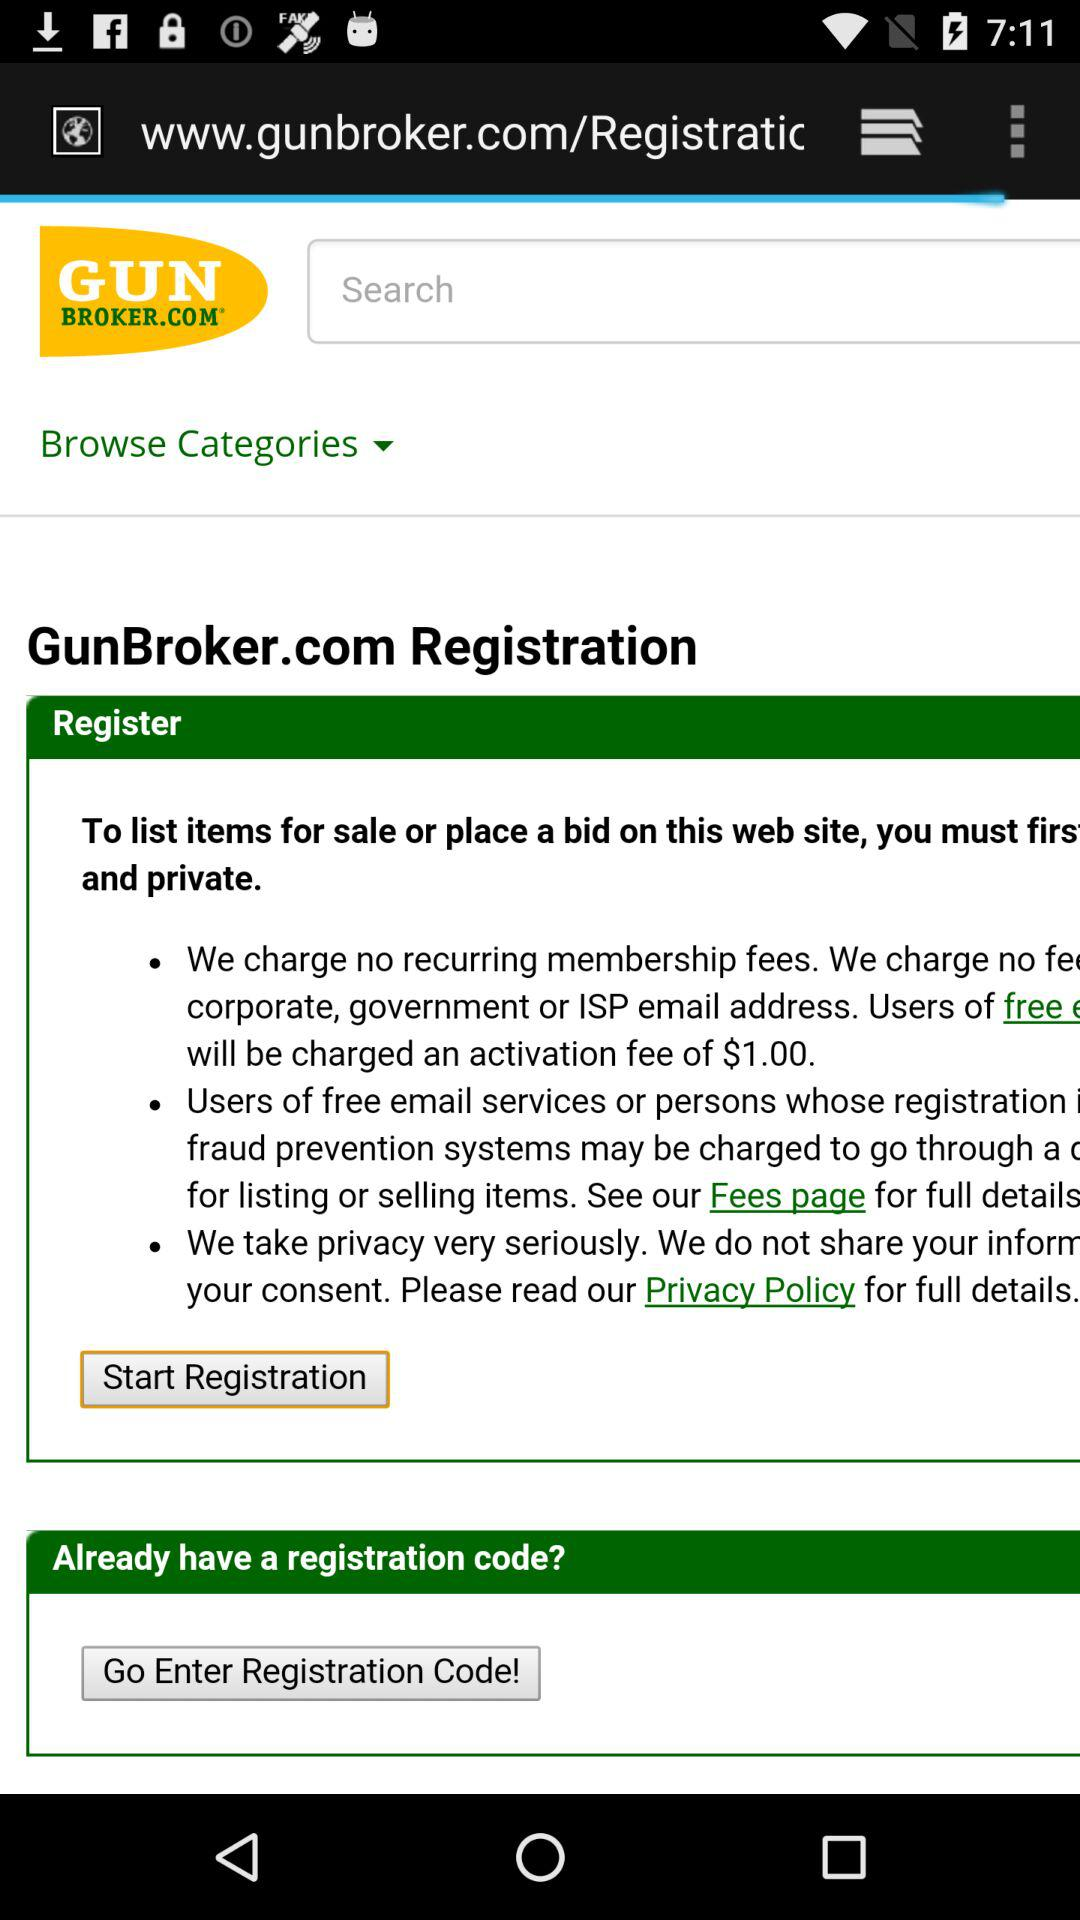What are the charges for the activation? The charges for the activation is $1. 